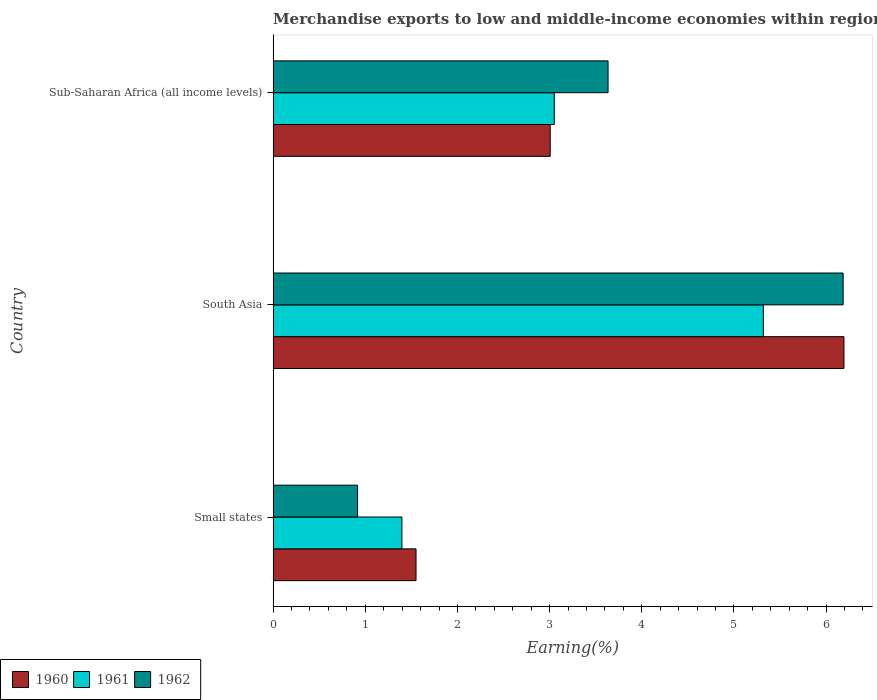Are the number of bars per tick equal to the number of legend labels?
Your answer should be very brief. Yes. Are the number of bars on each tick of the Y-axis equal?
Provide a succinct answer. Yes. How many bars are there on the 1st tick from the top?
Ensure brevity in your answer.  3. In how many cases, is the number of bars for a given country not equal to the number of legend labels?
Make the answer very short. 0. What is the percentage of amount earned from merchandise exports in 1962 in Sub-Saharan Africa (all income levels)?
Offer a very short reply. 3.63. Across all countries, what is the maximum percentage of amount earned from merchandise exports in 1962?
Your response must be concise. 6.19. Across all countries, what is the minimum percentage of amount earned from merchandise exports in 1961?
Provide a short and direct response. 1.4. In which country was the percentage of amount earned from merchandise exports in 1960 minimum?
Provide a short and direct response. Small states. What is the total percentage of amount earned from merchandise exports in 1962 in the graph?
Give a very brief answer. 10.74. What is the difference between the percentage of amount earned from merchandise exports in 1962 in Small states and that in South Asia?
Offer a terse response. -5.27. What is the difference between the percentage of amount earned from merchandise exports in 1961 in Sub-Saharan Africa (all income levels) and the percentage of amount earned from merchandise exports in 1962 in Small states?
Your response must be concise. 2.13. What is the average percentage of amount earned from merchandise exports in 1961 per country?
Provide a short and direct response. 3.26. What is the difference between the percentage of amount earned from merchandise exports in 1961 and percentage of amount earned from merchandise exports in 1960 in South Asia?
Provide a short and direct response. -0.88. In how many countries, is the percentage of amount earned from merchandise exports in 1961 greater than 1.8 %?
Provide a succinct answer. 2. What is the ratio of the percentage of amount earned from merchandise exports in 1960 in South Asia to that in Sub-Saharan Africa (all income levels)?
Offer a very short reply. 2.06. What is the difference between the highest and the second highest percentage of amount earned from merchandise exports in 1961?
Your answer should be very brief. 2.27. What is the difference between the highest and the lowest percentage of amount earned from merchandise exports in 1960?
Provide a succinct answer. 4.64. In how many countries, is the percentage of amount earned from merchandise exports in 1961 greater than the average percentage of amount earned from merchandise exports in 1961 taken over all countries?
Provide a succinct answer. 1. What does the 1st bar from the bottom in Small states represents?
Provide a succinct answer. 1960. How many bars are there?
Ensure brevity in your answer.  9. Are the values on the major ticks of X-axis written in scientific E-notation?
Offer a very short reply. No. Does the graph contain any zero values?
Make the answer very short. No. Does the graph contain grids?
Your response must be concise. No. Where does the legend appear in the graph?
Ensure brevity in your answer.  Bottom left. How many legend labels are there?
Your response must be concise. 3. What is the title of the graph?
Your answer should be very brief. Merchandise exports to low and middle-income economies within region. Does "1963" appear as one of the legend labels in the graph?
Give a very brief answer. No. What is the label or title of the X-axis?
Offer a very short reply. Earning(%). What is the label or title of the Y-axis?
Offer a very short reply. Country. What is the Earning(%) in 1960 in Small states?
Ensure brevity in your answer.  1.55. What is the Earning(%) of 1961 in Small states?
Provide a short and direct response. 1.4. What is the Earning(%) in 1962 in Small states?
Your answer should be compact. 0.92. What is the Earning(%) in 1960 in South Asia?
Offer a terse response. 6.19. What is the Earning(%) in 1961 in South Asia?
Give a very brief answer. 5.32. What is the Earning(%) in 1962 in South Asia?
Make the answer very short. 6.19. What is the Earning(%) of 1960 in Sub-Saharan Africa (all income levels)?
Your answer should be compact. 3.01. What is the Earning(%) of 1961 in Sub-Saharan Africa (all income levels)?
Give a very brief answer. 3.05. What is the Earning(%) of 1962 in Sub-Saharan Africa (all income levels)?
Make the answer very short. 3.63. Across all countries, what is the maximum Earning(%) of 1960?
Keep it short and to the point. 6.19. Across all countries, what is the maximum Earning(%) in 1961?
Make the answer very short. 5.32. Across all countries, what is the maximum Earning(%) in 1962?
Make the answer very short. 6.19. Across all countries, what is the minimum Earning(%) of 1960?
Make the answer very short. 1.55. Across all countries, what is the minimum Earning(%) of 1961?
Provide a short and direct response. 1.4. Across all countries, what is the minimum Earning(%) of 1962?
Your answer should be compact. 0.92. What is the total Earning(%) in 1960 in the graph?
Your answer should be very brief. 10.75. What is the total Earning(%) of 1961 in the graph?
Your response must be concise. 9.77. What is the total Earning(%) in 1962 in the graph?
Ensure brevity in your answer.  10.74. What is the difference between the Earning(%) in 1960 in Small states and that in South Asia?
Provide a short and direct response. -4.64. What is the difference between the Earning(%) of 1961 in Small states and that in South Asia?
Your answer should be very brief. -3.92. What is the difference between the Earning(%) of 1962 in Small states and that in South Asia?
Give a very brief answer. -5.27. What is the difference between the Earning(%) in 1960 in Small states and that in Sub-Saharan Africa (all income levels)?
Offer a very short reply. -1.46. What is the difference between the Earning(%) of 1961 in Small states and that in Sub-Saharan Africa (all income levels)?
Provide a short and direct response. -1.65. What is the difference between the Earning(%) in 1962 in Small states and that in Sub-Saharan Africa (all income levels)?
Give a very brief answer. -2.72. What is the difference between the Earning(%) in 1960 in South Asia and that in Sub-Saharan Africa (all income levels)?
Your answer should be very brief. 3.19. What is the difference between the Earning(%) in 1961 in South Asia and that in Sub-Saharan Africa (all income levels)?
Your answer should be compact. 2.27. What is the difference between the Earning(%) of 1962 in South Asia and that in Sub-Saharan Africa (all income levels)?
Offer a terse response. 2.55. What is the difference between the Earning(%) in 1960 in Small states and the Earning(%) in 1961 in South Asia?
Keep it short and to the point. -3.77. What is the difference between the Earning(%) of 1960 in Small states and the Earning(%) of 1962 in South Asia?
Offer a terse response. -4.63. What is the difference between the Earning(%) in 1961 in Small states and the Earning(%) in 1962 in South Asia?
Keep it short and to the point. -4.79. What is the difference between the Earning(%) in 1960 in Small states and the Earning(%) in 1961 in Sub-Saharan Africa (all income levels)?
Provide a short and direct response. -1.5. What is the difference between the Earning(%) in 1960 in Small states and the Earning(%) in 1962 in Sub-Saharan Africa (all income levels)?
Provide a short and direct response. -2.08. What is the difference between the Earning(%) in 1961 in Small states and the Earning(%) in 1962 in Sub-Saharan Africa (all income levels)?
Ensure brevity in your answer.  -2.24. What is the difference between the Earning(%) of 1960 in South Asia and the Earning(%) of 1961 in Sub-Saharan Africa (all income levels)?
Ensure brevity in your answer.  3.14. What is the difference between the Earning(%) of 1960 in South Asia and the Earning(%) of 1962 in Sub-Saharan Africa (all income levels)?
Make the answer very short. 2.56. What is the difference between the Earning(%) in 1961 in South Asia and the Earning(%) in 1962 in Sub-Saharan Africa (all income levels)?
Offer a very short reply. 1.68. What is the average Earning(%) in 1960 per country?
Ensure brevity in your answer.  3.58. What is the average Earning(%) of 1961 per country?
Your response must be concise. 3.26. What is the average Earning(%) of 1962 per country?
Your answer should be very brief. 3.58. What is the difference between the Earning(%) in 1960 and Earning(%) in 1961 in Small states?
Your answer should be very brief. 0.15. What is the difference between the Earning(%) in 1960 and Earning(%) in 1962 in Small states?
Ensure brevity in your answer.  0.63. What is the difference between the Earning(%) of 1961 and Earning(%) of 1962 in Small states?
Provide a short and direct response. 0.48. What is the difference between the Earning(%) of 1960 and Earning(%) of 1961 in South Asia?
Your response must be concise. 0.88. What is the difference between the Earning(%) in 1960 and Earning(%) in 1962 in South Asia?
Offer a very short reply. 0.01. What is the difference between the Earning(%) of 1961 and Earning(%) of 1962 in South Asia?
Provide a short and direct response. -0.87. What is the difference between the Earning(%) in 1960 and Earning(%) in 1961 in Sub-Saharan Africa (all income levels)?
Make the answer very short. -0.04. What is the difference between the Earning(%) in 1960 and Earning(%) in 1962 in Sub-Saharan Africa (all income levels)?
Your answer should be very brief. -0.63. What is the difference between the Earning(%) in 1961 and Earning(%) in 1962 in Sub-Saharan Africa (all income levels)?
Keep it short and to the point. -0.58. What is the ratio of the Earning(%) of 1960 in Small states to that in South Asia?
Ensure brevity in your answer.  0.25. What is the ratio of the Earning(%) in 1961 in Small states to that in South Asia?
Your response must be concise. 0.26. What is the ratio of the Earning(%) of 1962 in Small states to that in South Asia?
Your response must be concise. 0.15. What is the ratio of the Earning(%) of 1960 in Small states to that in Sub-Saharan Africa (all income levels)?
Your response must be concise. 0.52. What is the ratio of the Earning(%) of 1961 in Small states to that in Sub-Saharan Africa (all income levels)?
Your answer should be compact. 0.46. What is the ratio of the Earning(%) in 1962 in Small states to that in Sub-Saharan Africa (all income levels)?
Make the answer very short. 0.25. What is the ratio of the Earning(%) in 1960 in South Asia to that in Sub-Saharan Africa (all income levels)?
Your answer should be very brief. 2.06. What is the ratio of the Earning(%) of 1961 in South Asia to that in Sub-Saharan Africa (all income levels)?
Your answer should be very brief. 1.74. What is the ratio of the Earning(%) of 1962 in South Asia to that in Sub-Saharan Africa (all income levels)?
Offer a very short reply. 1.7. What is the difference between the highest and the second highest Earning(%) in 1960?
Your answer should be compact. 3.19. What is the difference between the highest and the second highest Earning(%) of 1961?
Keep it short and to the point. 2.27. What is the difference between the highest and the second highest Earning(%) in 1962?
Your answer should be compact. 2.55. What is the difference between the highest and the lowest Earning(%) in 1960?
Keep it short and to the point. 4.64. What is the difference between the highest and the lowest Earning(%) in 1961?
Your answer should be very brief. 3.92. What is the difference between the highest and the lowest Earning(%) in 1962?
Offer a terse response. 5.27. 